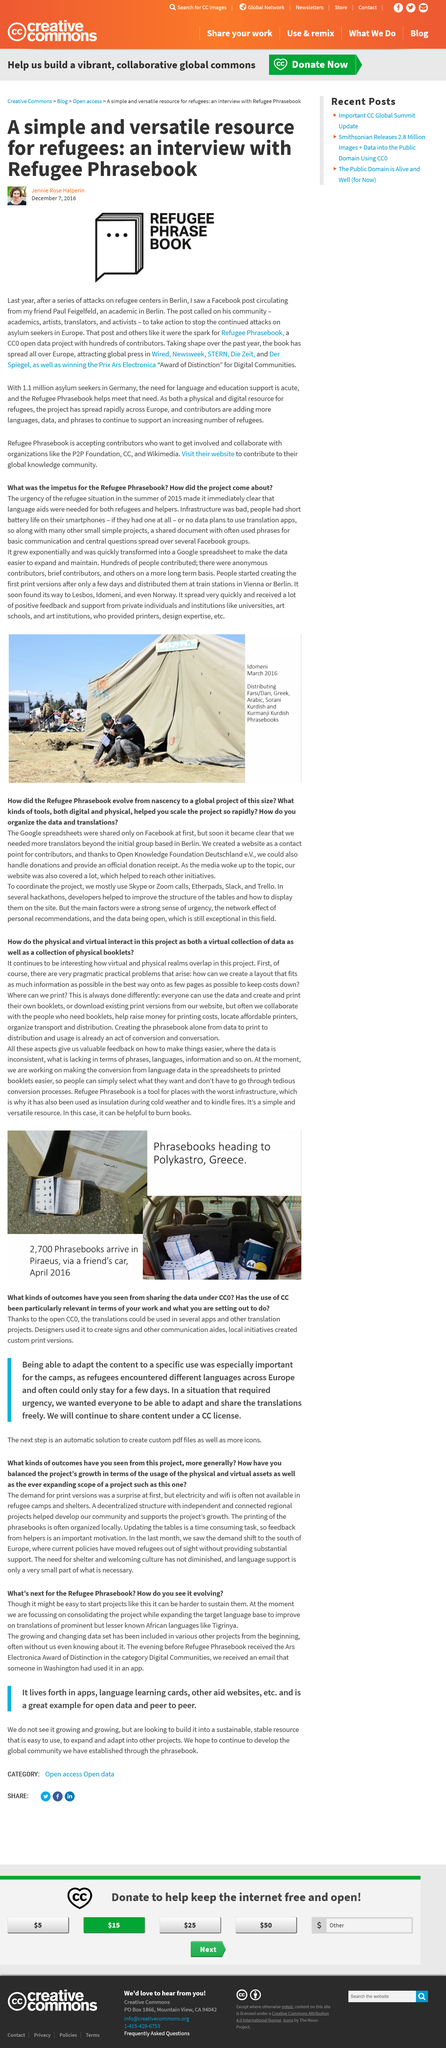Mention a couple of crucial points in this snapshot. The Refugee Phrasebook was inspired by a series of attacks on refugee centers that left many innocent people traumatized and in need of assistance. The book received the Award of Distinction for Digital Communities, which is a prestigious recognition of its excellence in the field. The spread of a particular social media platform was initially facilitated by Facebook. 